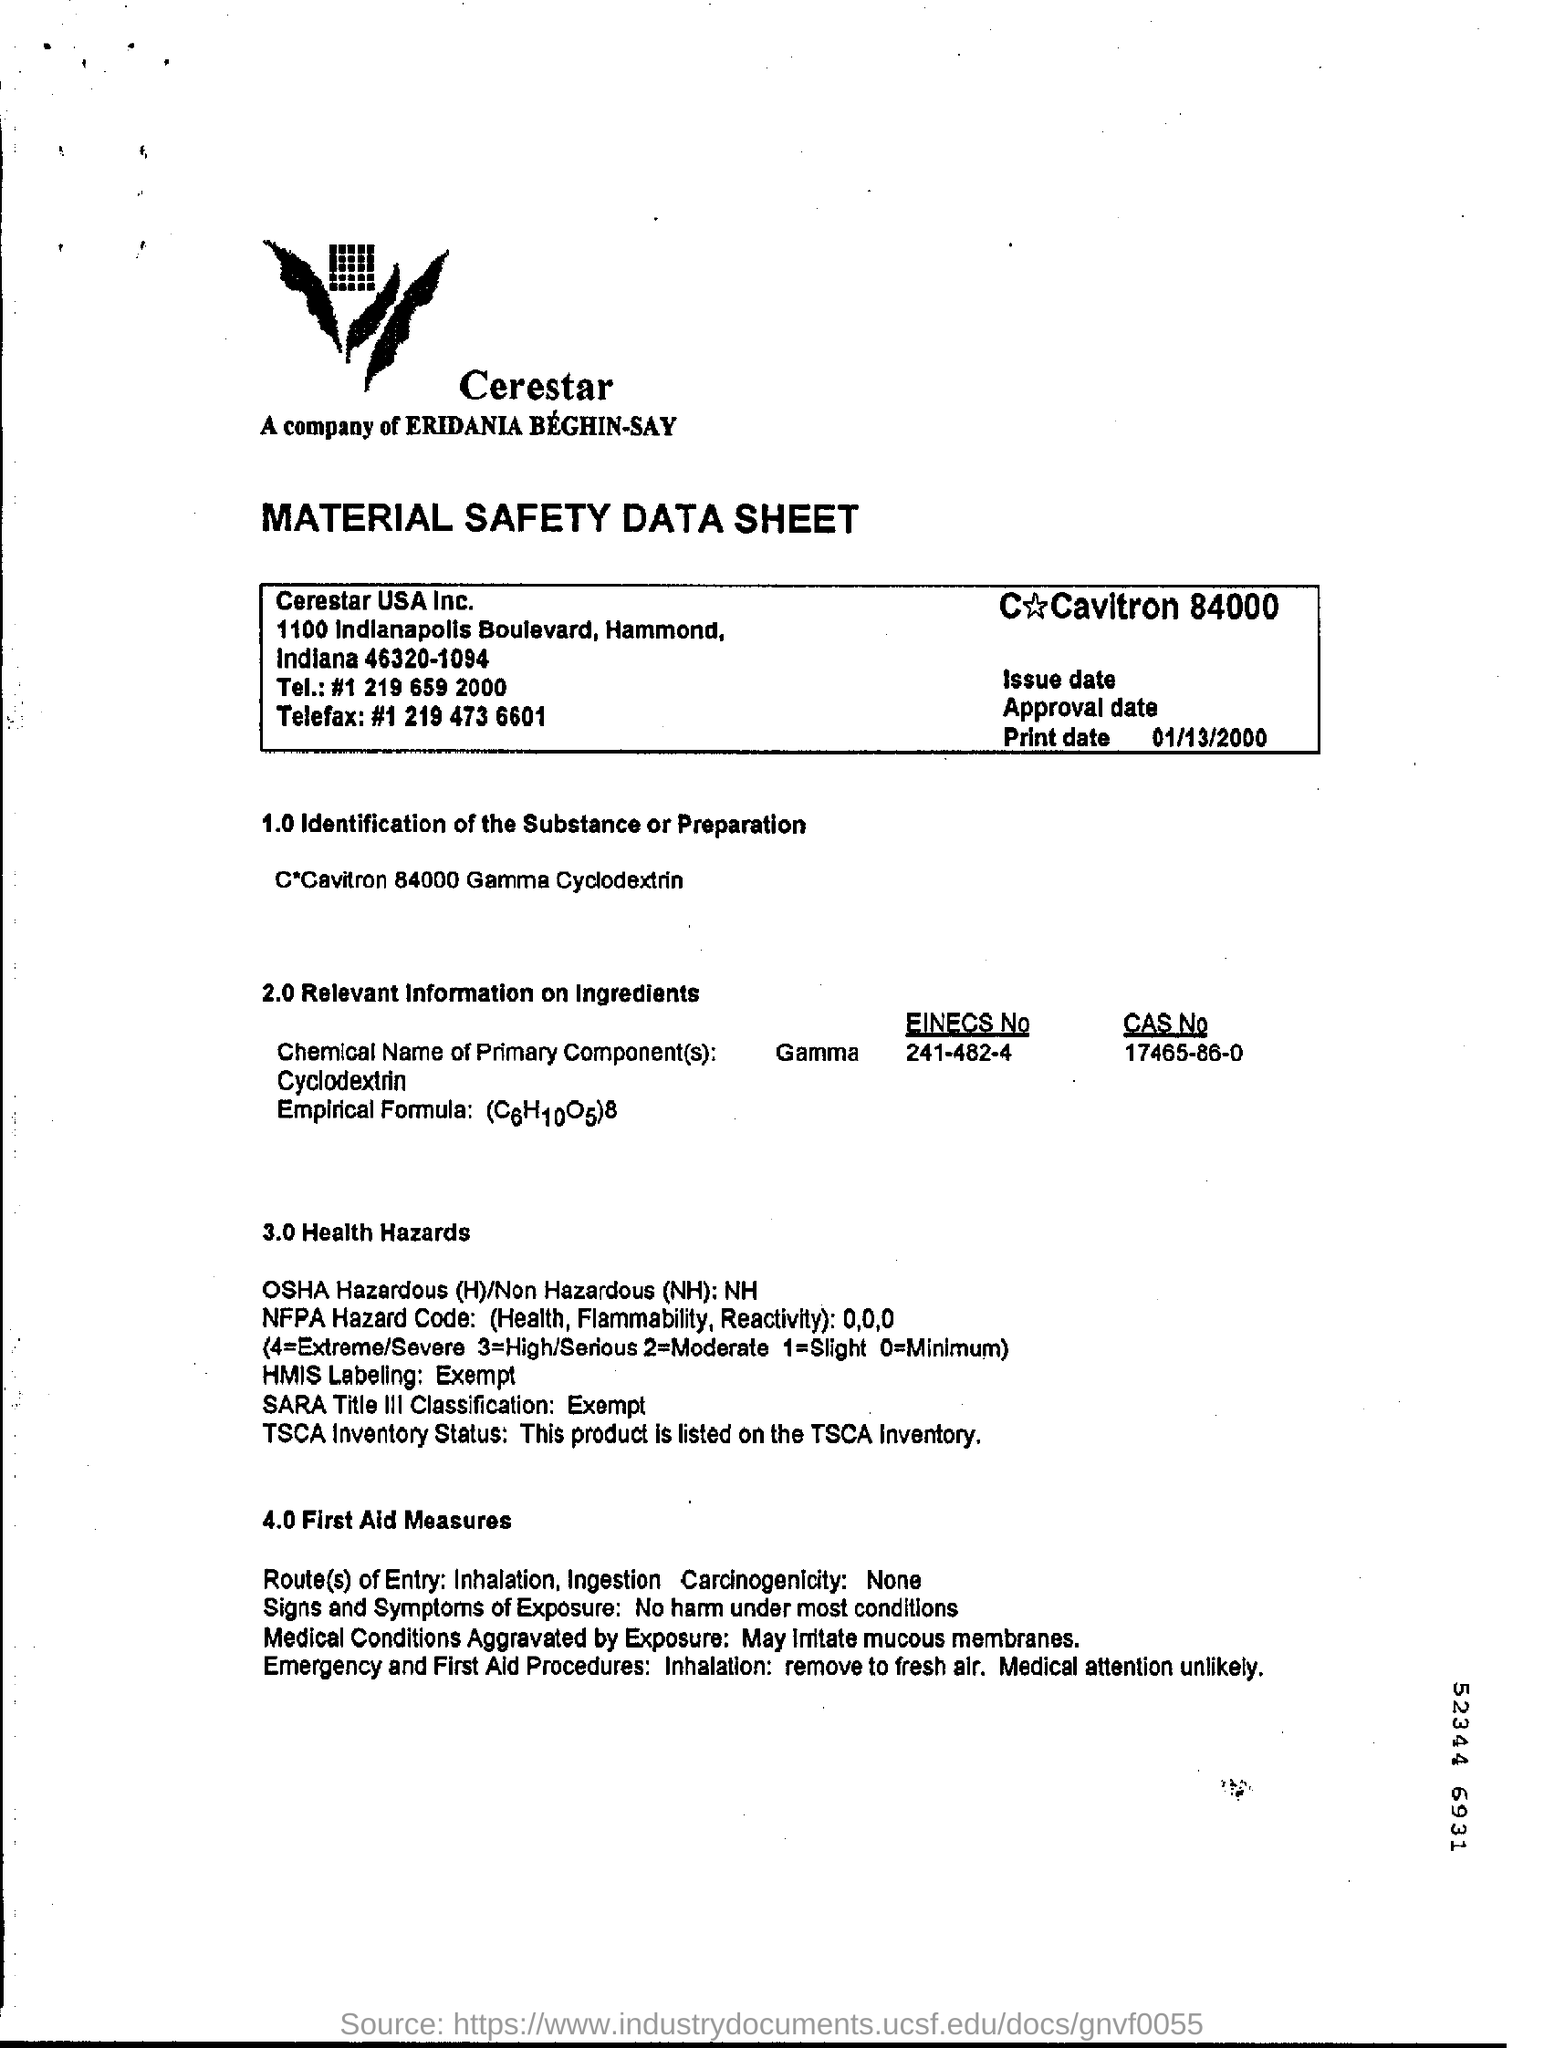Identify some key points in this picture. This data sheet appears to be a Material Safety Data Sheet. The mode of entry for a substance can be through inhalation, ingestion, or other routes. 